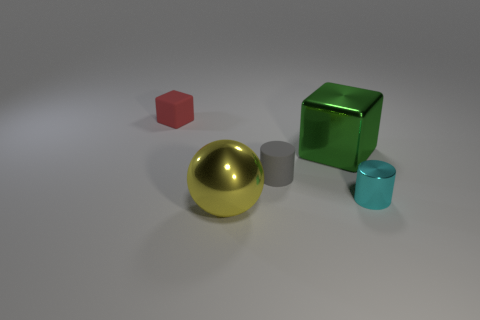Add 4 big blocks. How many objects exist? 9 Subtract all cubes. How many objects are left? 3 Add 5 tiny cyan cylinders. How many tiny cyan cylinders exist? 6 Subtract 0 green cylinders. How many objects are left? 5 Subtract all gray cylinders. Subtract all red blocks. How many cylinders are left? 1 Subtract all large purple matte balls. Subtract all metallic balls. How many objects are left? 4 Add 5 small red matte things. How many small red matte things are left? 6 